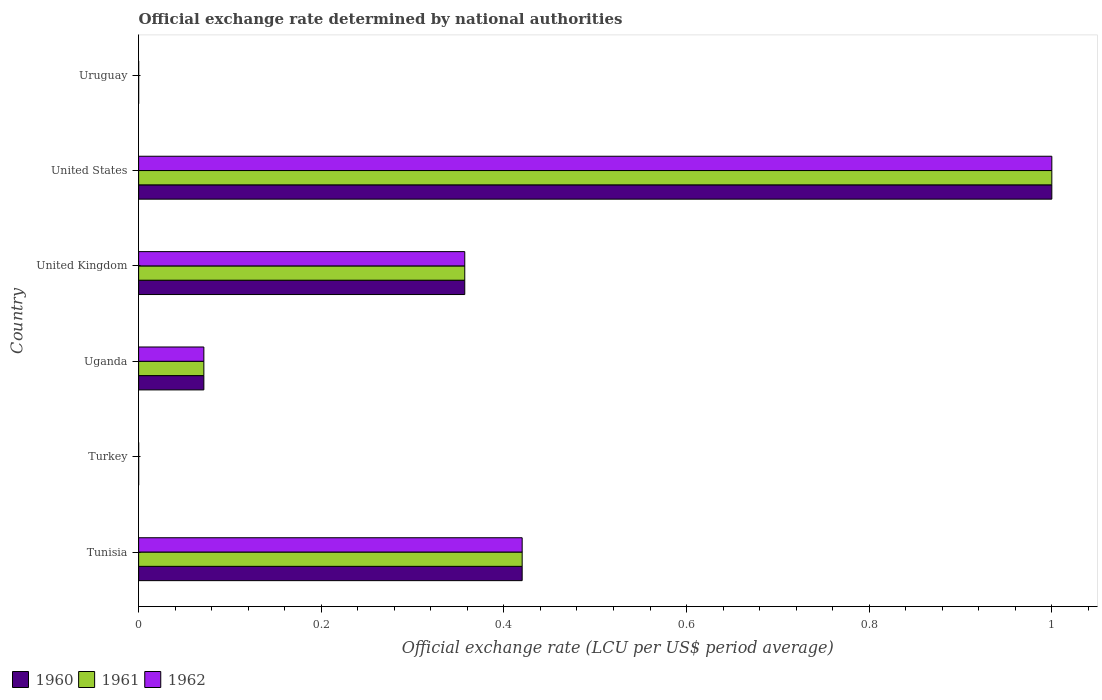How many different coloured bars are there?
Provide a succinct answer. 3. How many bars are there on the 5th tick from the top?
Offer a very short reply. 3. What is the official exchange rate in 1960 in Uruguay?
Your answer should be very brief. 1.12966666666667e-5. Across all countries, what is the minimum official exchange rate in 1961?
Your answer should be compact. 9.02e-6. What is the total official exchange rate in 1962 in the graph?
Make the answer very short. 1.85. What is the difference between the official exchange rate in 1962 in United Kingdom and that in Uruguay?
Make the answer very short. 0.36. What is the difference between the official exchange rate in 1962 in Uganda and the official exchange rate in 1960 in United States?
Provide a short and direct response. -0.93. What is the average official exchange rate in 1961 per country?
Provide a succinct answer. 0.31. What is the ratio of the official exchange rate in 1961 in Tunisia to that in Uruguay?
Your answer should be compact. 3.82e+04. What is the difference between the highest and the second highest official exchange rate in 1961?
Ensure brevity in your answer.  0.58. What is the difference between the highest and the lowest official exchange rate in 1960?
Your answer should be compact. 1. How many bars are there?
Ensure brevity in your answer.  18. Are all the bars in the graph horizontal?
Ensure brevity in your answer.  Yes. How many countries are there in the graph?
Offer a very short reply. 6. What is the difference between two consecutive major ticks on the X-axis?
Give a very brief answer. 0.2. Does the graph contain grids?
Your response must be concise. No. How many legend labels are there?
Ensure brevity in your answer.  3. What is the title of the graph?
Provide a succinct answer. Official exchange rate determined by national authorities. What is the label or title of the X-axis?
Ensure brevity in your answer.  Official exchange rate (LCU per US$ period average). What is the Official exchange rate (LCU per US$ period average) in 1960 in Tunisia?
Keep it short and to the point. 0.42. What is the Official exchange rate (LCU per US$ period average) in 1961 in Tunisia?
Ensure brevity in your answer.  0.42. What is the Official exchange rate (LCU per US$ period average) in 1962 in Tunisia?
Provide a short and direct response. 0.42. What is the Official exchange rate (LCU per US$ period average) of 1960 in Turkey?
Your response must be concise. 9.01691666658333e-6. What is the Official exchange rate (LCU per US$ period average) of 1961 in Turkey?
Keep it short and to the point. 9.02e-6. What is the Official exchange rate (LCU per US$ period average) of 1962 in Turkey?
Keep it short and to the point. 9.02e-6. What is the Official exchange rate (LCU per US$ period average) in 1960 in Uganda?
Your answer should be very brief. 0.07. What is the Official exchange rate (LCU per US$ period average) of 1961 in Uganda?
Keep it short and to the point. 0.07. What is the Official exchange rate (LCU per US$ period average) in 1962 in Uganda?
Make the answer very short. 0.07. What is the Official exchange rate (LCU per US$ period average) of 1960 in United Kingdom?
Provide a short and direct response. 0.36. What is the Official exchange rate (LCU per US$ period average) in 1961 in United Kingdom?
Your answer should be compact. 0.36. What is the Official exchange rate (LCU per US$ period average) of 1962 in United Kingdom?
Your answer should be very brief. 0.36. What is the Official exchange rate (LCU per US$ period average) of 1961 in United States?
Provide a succinct answer. 1. What is the Official exchange rate (LCU per US$ period average) of 1962 in United States?
Offer a terse response. 1. What is the Official exchange rate (LCU per US$ period average) in 1960 in Uruguay?
Make the answer very short. 1.12966666666667e-5. What is the Official exchange rate (LCU per US$ period average) of 1961 in Uruguay?
Ensure brevity in your answer.  1.10091666666667e-5. What is the Official exchange rate (LCU per US$ period average) in 1962 in Uruguay?
Provide a short and direct response. 1.098e-5. Across all countries, what is the maximum Official exchange rate (LCU per US$ period average) of 1960?
Offer a terse response. 1. Across all countries, what is the maximum Official exchange rate (LCU per US$ period average) in 1961?
Make the answer very short. 1. Across all countries, what is the minimum Official exchange rate (LCU per US$ period average) of 1960?
Give a very brief answer. 9.01691666658333e-6. Across all countries, what is the minimum Official exchange rate (LCU per US$ period average) of 1961?
Make the answer very short. 9.02e-6. Across all countries, what is the minimum Official exchange rate (LCU per US$ period average) in 1962?
Your answer should be very brief. 9.02e-6. What is the total Official exchange rate (LCU per US$ period average) of 1960 in the graph?
Ensure brevity in your answer.  1.85. What is the total Official exchange rate (LCU per US$ period average) of 1961 in the graph?
Your response must be concise. 1.85. What is the total Official exchange rate (LCU per US$ period average) in 1962 in the graph?
Provide a succinct answer. 1.85. What is the difference between the Official exchange rate (LCU per US$ period average) of 1960 in Tunisia and that in Turkey?
Make the answer very short. 0.42. What is the difference between the Official exchange rate (LCU per US$ period average) of 1961 in Tunisia and that in Turkey?
Provide a short and direct response. 0.42. What is the difference between the Official exchange rate (LCU per US$ period average) in 1962 in Tunisia and that in Turkey?
Give a very brief answer. 0.42. What is the difference between the Official exchange rate (LCU per US$ period average) of 1960 in Tunisia and that in Uganda?
Provide a succinct answer. 0.35. What is the difference between the Official exchange rate (LCU per US$ period average) of 1961 in Tunisia and that in Uganda?
Offer a very short reply. 0.35. What is the difference between the Official exchange rate (LCU per US$ period average) of 1962 in Tunisia and that in Uganda?
Your answer should be very brief. 0.35. What is the difference between the Official exchange rate (LCU per US$ period average) in 1960 in Tunisia and that in United Kingdom?
Offer a very short reply. 0.06. What is the difference between the Official exchange rate (LCU per US$ period average) in 1961 in Tunisia and that in United Kingdom?
Your answer should be compact. 0.06. What is the difference between the Official exchange rate (LCU per US$ period average) of 1962 in Tunisia and that in United Kingdom?
Your answer should be very brief. 0.06. What is the difference between the Official exchange rate (LCU per US$ period average) in 1960 in Tunisia and that in United States?
Offer a very short reply. -0.58. What is the difference between the Official exchange rate (LCU per US$ period average) of 1961 in Tunisia and that in United States?
Ensure brevity in your answer.  -0.58. What is the difference between the Official exchange rate (LCU per US$ period average) of 1962 in Tunisia and that in United States?
Your answer should be compact. -0.58. What is the difference between the Official exchange rate (LCU per US$ period average) in 1960 in Tunisia and that in Uruguay?
Provide a short and direct response. 0.42. What is the difference between the Official exchange rate (LCU per US$ period average) of 1961 in Tunisia and that in Uruguay?
Offer a terse response. 0.42. What is the difference between the Official exchange rate (LCU per US$ period average) of 1962 in Tunisia and that in Uruguay?
Ensure brevity in your answer.  0.42. What is the difference between the Official exchange rate (LCU per US$ period average) of 1960 in Turkey and that in Uganda?
Offer a terse response. -0.07. What is the difference between the Official exchange rate (LCU per US$ period average) of 1961 in Turkey and that in Uganda?
Give a very brief answer. -0.07. What is the difference between the Official exchange rate (LCU per US$ period average) in 1962 in Turkey and that in Uganda?
Make the answer very short. -0.07. What is the difference between the Official exchange rate (LCU per US$ period average) of 1960 in Turkey and that in United Kingdom?
Your answer should be compact. -0.36. What is the difference between the Official exchange rate (LCU per US$ period average) in 1961 in Turkey and that in United Kingdom?
Provide a succinct answer. -0.36. What is the difference between the Official exchange rate (LCU per US$ period average) in 1962 in Turkey and that in United Kingdom?
Your answer should be very brief. -0.36. What is the difference between the Official exchange rate (LCU per US$ period average) in 1960 in Turkey and that in Uruguay?
Offer a terse response. -0. What is the difference between the Official exchange rate (LCU per US$ period average) of 1960 in Uganda and that in United Kingdom?
Provide a short and direct response. -0.29. What is the difference between the Official exchange rate (LCU per US$ period average) in 1961 in Uganda and that in United Kingdom?
Make the answer very short. -0.29. What is the difference between the Official exchange rate (LCU per US$ period average) in 1962 in Uganda and that in United Kingdom?
Give a very brief answer. -0.29. What is the difference between the Official exchange rate (LCU per US$ period average) in 1960 in Uganda and that in United States?
Provide a short and direct response. -0.93. What is the difference between the Official exchange rate (LCU per US$ period average) of 1961 in Uganda and that in United States?
Offer a very short reply. -0.93. What is the difference between the Official exchange rate (LCU per US$ period average) in 1962 in Uganda and that in United States?
Keep it short and to the point. -0.93. What is the difference between the Official exchange rate (LCU per US$ period average) of 1960 in Uganda and that in Uruguay?
Provide a short and direct response. 0.07. What is the difference between the Official exchange rate (LCU per US$ period average) in 1961 in Uganda and that in Uruguay?
Provide a short and direct response. 0.07. What is the difference between the Official exchange rate (LCU per US$ period average) of 1962 in Uganda and that in Uruguay?
Offer a very short reply. 0.07. What is the difference between the Official exchange rate (LCU per US$ period average) of 1960 in United Kingdom and that in United States?
Your response must be concise. -0.64. What is the difference between the Official exchange rate (LCU per US$ period average) of 1961 in United Kingdom and that in United States?
Offer a terse response. -0.64. What is the difference between the Official exchange rate (LCU per US$ period average) in 1962 in United Kingdom and that in United States?
Provide a succinct answer. -0.64. What is the difference between the Official exchange rate (LCU per US$ period average) of 1960 in United Kingdom and that in Uruguay?
Keep it short and to the point. 0.36. What is the difference between the Official exchange rate (LCU per US$ period average) in 1961 in United Kingdom and that in Uruguay?
Your answer should be very brief. 0.36. What is the difference between the Official exchange rate (LCU per US$ period average) in 1962 in United Kingdom and that in Uruguay?
Provide a succinct answer. 0.36. What is the difference between the Official exchange rate (LCU per US$ period average) in 1961 in United States and that in Uruguay?
Your answer should be compact. 1. What is the difference between the Official exchange rate (LCU per US$ period average) of 1962 in United States and that in Uruguay?
Provide a succinct answer. 1. What is the difference between the Official exchange rate (LCU per US$ period average) in 1960 in Tunisia and the Official exchange rate (LCU per US$ period average) in 1961 in Turkey?
Keep it short and to the point. 0.42. What is the difference between the Official exchange rate (LCU per US$ period average) in 1960 in Tunisia and the Official exchange rate (LCU per US$ period average) in 1962 in Turkey?
Make the answer very short. 0.42. What is the difference between the Official exchange rate (LCU per US$ period average) in 1961 in Tunisia and the Official exchange rate (LCU per US$ period average) in 1962 in Turkey?
Offer a terse response. 0.42. What is the difference between the Official exchange rate (LCU per US$ period average) in 1960 in Tunisia and the Official exchange rate (LCU per US$ period average) in 1961 in Uganda?
Ensure brevity in your answer.  0.35. What is the difference between the Official exchange rate (LCU per US$ period average) of 1960 in Tunisia and the Official exchange rate (LCU per US$ period average) of 1962 in Uganda?
Give a very brief answer. 0.35. What is the difference between the Official exchange rate (LCU per US$ period average) of 1961 in Tunisia and the Official exchange rate (LCU per US$ period average) of 1962 in Uganda?
Keep it short and to the point. 0.35. What is the difference between the Official exchange rate (LCU per US$ period average) in 1960 in Tunisia and the Official exchange rate (LCU per US$ period average) in 1961 in United Kingdom?
Keep it short and to the point. 0.06. What is the difference between the Official exchange rate (LCU per US$ period average) in 1960 in Tunisia and the Official exchange rate (LCU per US$ period average) in 1962 in United Kingdom?
Provide a succinct answer. 0.06. What is the difference between the Official exchange rate (LCU per US$ period average) in 1961 in Tunisia and the Official exchange rate (LCU per US$ period average) in 1962 in United Kingdom?
Your answer should be very brief. 0.06. What is the difference between the Official exchange rate (LCU per US$ period average) of 1960 in Tunisia and the Official exchange rate (LCU per US$ period average) of 1961 in United States?
Offer a very short reply. -0.58. What is the difference between the Official exchange rate (LCU per US$ period average) of 1960 in Tunisia and the Official exchange rate (LCU per US$ period average) of 1962 in United States?
Offer a very short reply. -0.58. What is the difference between the Official exchange rate (LCU per US$ period average) in 1961 in Tunisia and the Official exchange rate (LCU per US$ period average) in 1962 in United States?
Keep it short and to the point. -0.58. What is the difference between the Official exchange rate (LCU per US$ period average) of 1960 in Tunisia and the Official exchange rate (LCU per US$ period average) of 1961 in Uruguay?
Offer a terse response. 0.42. What is the difference between the Official exchange rate (LCU per US$ period average) of 1960 in Tunisia and the Official exchange rate (LCU per US$ period average) of 1962 in Uruguay?
Your answer should be very brief. 0.42. What is the difference between the Official exchange rate (LCU per US$ period average) in 1961 in Tunisia and the Official exchange rate (LCU per US$ period average) in 1962 in Uruguay?
Provide a succinct answer. 0.42. What is the difference between the Official exchange rate (LCU per US$ period average) in 1960 in Turkey and the Official exchange rate (LCU per US$ period average) in 1961 in Uganda?
Your response must be concise. -0.07. What is the difference between the Official exchange rate (LCU per US$ period average) in 1960 in Turkey and the Official exchange rate (LCU per US$ period average) in 1962 in Uganda?
Offer a very short reply. -0.07. What is the difference between the Official exchange rate (LCU per US$ period average) in 1961 in Turkey and the Official exchange rate (LCU per US$ period average) in 1962 in Uganda?
Offer a very short reply. -0.07. What is the difference between the Official exchange rate (LCU per US$ period average) in 1960 in Turkey and the Official exchange rate (LCU per US$ period average) in 1961 in United Kingdom?
Give a very brief answer. -0.36. What is the difference between the Official exchange rate (LCU per US$ period average) of 1960 in Turkey and the Official exchange rate (LCU per US$ period average) of 1962 in United Kingdom?
Your answer should be compact. -0.36. What is the difference between the Official exchange rate (LCU per US$ period average) of 1961 in Turkey and the Official exchange rate (LCU per US$ period average) of 1962 in United Kingdom?
Offer a very short reply. -0.36. What is the difference between the Official exchange rate (LCU per US$ period average) of 1961 in Turkey and the Official exchange rate (LCU per US$ period average) of 1962 in Uruguay?
Your response must be concise. -0. What is the difference between the Official exchange rate (LCU per US$ period average) of 1960 in Uganda and the Official exchange rate (LCU per US$ period average) of 1961 in United Kingdom?
Give a very brief answer. -0.29. What is the difference between the Official exchange rate (LCU per US$ period average) of 1960 in Uganda and the Official exchange rate (LCU per US$ period average) of 1962 in United Kingdom?
Give a very brief answer. -0.29. What is the difference between the Official exchange rate (LCU per US$ period average) of 1961 in Uganda and the Official exchange rate (LCU per US$ period average) of 1962 in United Kingdom?
Provide a succinct answer. -0.29. What is the difference between the Official exchange rate (LCU per US$ period average) of 1960 in Uganda and the Official exchange rate (LCU per US$ period average) of 1961 in United States?
Offer a very short reply. -0.93. What is the difference between the Official exchange rate (LCU per US$ period average) in 1960 in Uganda and the Official exchange rate (LCU per US$ period average) in 1962 in United States?
Provide a short and direct response. -0.93. What is the difference between the Official exchange rate (LCU per US$ period average) of 1961 in Uganda and the Official exchange rate (LCU per US$ period average) of 1962 in United States?
Give a very brief answer. -0.93. What is the difference between the Official exchange rate (LCU per US$ period average) of 1960 in Uganda and the Official exchange rate (LCU per US$ period average) of 1961 in Uruguay?
Provide a short and direct response. 0.07. What is the difference between the Official exchange rate (LCU per US$ period average) in 1960 in Uganda and the Official exchange rate (LCU per US$ period average) in 1962 in Uruguay?
Offer a very short reply. 0.07. What is the difference between the Official exchange rate (LCU per US$ period average) in 1961 in Uganda and the Official exchange rate (LCU per US$ period average) in 1962 in Uruguay?
Your response must be concise. 0.07. What is the difference between the Official exchange rate (LCU per US$ period average) in 1960 in United Kingdom and the Official exchange rate (LCU per US$ period average) in 1961 in United States?
Your answer should be very brief. -0.64. What is the difference between the Official exchange rate (LCU per US$ period average) in 1960 in United Kingdom and the Official exchange rate (LCU per US$ period average) in 1962 in United States?
Provide a succinct answer. -0.64. What is the difference between the Official exchange rate (LCU per US$ period average) in 1961 in United Kingdom and the Official exchange rate (LCU per US$ period average) in 1962 in United States?
Keep it short and to the point. -0.64. What is the difference between the Official exchange rate (LCU per US$ period average) in 1960 in United Kingdom and the Official exchange rate (LCU per US$ period average) in 1961 in Uruguay?
Ensure brevity in your answer.  0.36. What is the difference between the Official exchange rate (LCU per US$ period average) in 1960 in United Kingdom and the Official exchange rate (LCU per US$ period average) in 1962 in Uruguay?
Make the answer very short. 0.36. What is the difference between the Official exchange rate (LCU per US$ period average) of 1961 in United Kingdom and the Official exchange rate (LCU per US$ period average) of 1962 in Uruguay?
Provide a succinct answer. 0.36. What is the difference between the Official exchange rate (LCU per US$ period average) in 1961 in United States and the Official exchange rate (LCU per US$ period average) in 1962 in Uruguay?
Your response must be concise. 1. What is the average Official exchange rate (LCU per US$ period average) of 1960 per country?
Make the answer very short. 0.31. What is the average Official exchange rate (LCU per US$ period average) of 1961 per country?
Offer a very short reply. 0.31. What is the average Official exchange rate (LCU per US$ period average) in 1962 per country?
Give a very brief answer. 0.31. What is the difference between the Official exchange rate (LCU per US$ period average) in 1960 and Official exchange rate (LCU per US$ period average) in 1961 in Tunisia?
Provide a short and direct response. 0. What is the difference between the Official exchange rate (LCU per US$ period average) in 1960 and Official exchange rate (LCU per US$ period average) in 1962 in Tunisia?
Provide a short and direct response. 0. What is the difference between the Official exchange rate (LCU per US$ period average) of 1960 and Official exchange rate (LCU per US$ period average) of 1961 in Uganda?
Provide a short and direct response. 0. What is the difference between the Official exchange rate (LCU per US$ period average) of 1960 and Official exchange rate (LCU per US$ period average) of 1962 in Uganda?
Offer a very short reply. 0. What is the difference between the Official exchange rate (LCU per US$ period average) of 1960 and Official exchange rate (LCU per US$ period average) of 1961 in United Kingdom?
Give a very brief answer. 0. What is the difference between the Official exchange rate (LCU per US$ period average) of 1960 and Official exchange rate (LCU per US$ period average) of 1961 in Uruguay?
Your response must be concise. 0. What is the ratio of the Official exchange rate (LCU per US$ period average) in 1960 in Tunisia to that in Turkey?
Provide a short and direct response. 4.66e+04. What is the ratio of the Official exchange rate (LCU per US$ period average) in 1961 in Tunisia to that in Turkey?
Your response must be concise. 4.66e+04. What is the ratio of the Official exchange rate (LCU per US$ period average) of 1962 in Tunisia to that in Turkey?
Your response must be concise. 4.66e+04. What is the ratio of the Official exchange rate (LCU per US$ period average) of 1960 in Tunisia to that in Uganda?
Your response must be concise. 5.88. What is the ratio of the Official exchange rate (LCU per US$ period average) in 1961 in Tunisia to that in Uganda?
Offer a very short reply. 5.88. What is the ratio of the Official exchange rate (LCU per US$ period average) in 1962 in Tunisia to that in Uganda?
Your answer should be very brief. 5.88. What is the ratio of the Official exchange rate (LCU per US$ period average) in 1960 in Tunisia to that in United Kingdom?
Your answer should be compact. 1.18. What is the ratio of the Official exchange rate (LCU per US$ period average) of 1961 in Tunisia to that in United Kingdom?
Provide a succinct answer. 1.18. What is the ratio of the Official exchange rate (LCU per US$ period average) in 1962 in Tunisia to that in United Kingdom?
Make the answer very short. 1.18. What is the ratio of the Official exchange rate (LCU per US$ period average) in 1960 in Tunisia to that in United States?
Your response must be concise. 0.42. What is the ratio of the Official exchange rate (LCU per US$ period average) of 1961 in Tunisia to that in United States?
Make the answer very short. 0.42. What is the ratio of the Official exchange rate (LCU per US$ period average) of 1962 in Tunisia to that in United States?
Your response must be concise. 0.42. What is the ratio of the Official exchange rate (LCU per US$ period average) in 1960 in Tunisia to that in Uruguay?
Offer a terse response. 3.72e+04. What is the ratio of the Official exchange rate (LCU per US$ period average) in 1961 in Tunisia to that in Uruguay?
Offer a terse response. 3.82e+04. What is the ratio of the Official exchange rate (LCU per US$ period average) in 1962 in Tunisia to that in Uruguay?
Provide a short and direct response. 3.83e+04. What is the ratio of the Official exchange rate (LCU per US$ period average) of 1961 in Turkey to that in United Kingdom?
Offer a very short reply. 0. What is the ratio of the Official exchange rate (LCU per US$ period average) in 1962 in Turkey to that in United Kingdom?
Offer a terse response. 0. What is the ratio of the Official exchange rate (LCU per US$ period average) of 1962 in Turkey to that in United States?
Offer a very short reply. 0. What is the ratio of the Official exchange rate (LCU per US$ period average) in 1960 in Turkey to that in Uruguay?
Make the answer very short. 0.8. What is the ratio of the Official exchange rate (LCU per US$ period average) in 1961 in Turkey to that in Uruguay?
Provide a succinct answer. 0.82. What is the ratio of the Official exchange rate (LCU per US$ period average) in 1962 in Turkey to that in Uruguay?
Your answer should be compact. 0.82. What is the ratio of the Official exchange rate (LCU per US$ period average) of 1960 in Uganda to that in United Kingdom?
Your answer should be very brief. 0.2. What is the ratio of the Official exchange rate (LCU per US$ period average) in 1962 in Uganda to that in United Kingdom?
Provide a short and direct response. 0.2. What is the ratio of the Official exchange rate (LCU per US$ period average) of 1960 in Uganda to that in United States?
Make the answer very short. 0.07. What is the ratio of the Official exchange rate (LCU per US$ period average) of 1961 in Uganda to that in United States?
Your response must be concise. 0.07. What is the ratio of the Official exchange rate (LCU per US$ period average) of 1962 in Uganda to that in United States?
Make the answer very short. 0.07. What is the ratio of the Official exchange rate (LCU per US$ period average) of 1960 in Uganda to that in Uruguay?
Keep it short and to the point. 6323.1. What is the ratio of the Official exchange rate (LCU per US$ period average) of 1961 in Uganda to that in Uruguay?
Provide a succinct answer. 6488.23. What is the ratio of the Official exchange rate (LCU per US$ period average) in 1962 in Uganda to that in Uruguay?
Offer a very short reply. 6505.46. What is the ratio of the Official exchange rate (LCU per US$ period average) in 1960 in United Kingdom to that in United States?
Provide a short and direct response. 0.36. What is the ratio of the Official exchange rate (LCU per US$ period average) in 1961 in United Kingdom to that in United States?
Ensure brevity in your answer.  0.36. What is the ratio of the Official exchange rate (LCU per US$ period average) in 1962 in United Kingdom to that in United States?
Your answer should be very brief. 0.36. What is the ratio of the Official exchange rate (LCU per US$ period average) in 1960 in United Kingdom to that in Uruguay?
Provide a short and direct response. 3.16e+04. What is the ratio of the Official exchange rate (LCU per US$ period average) in 1961 in United Kingdom to that in Uruguay?
Your answer should be compact. 3.24e+04. What is the ratio of the Official exchange rate (LCU per US$ period average) in 1962 in United Kingdom to that in Uruguay?
Ensure brevity in your answer.  3.25e+04. What is the ratio of the Official exchange rate (LCU per US$ period average) of 1960 in United States to that in Uruguay?
Offer a very short reply. 8.85e+04. What is the ratio of the Official exchange rate (LCU per US$ period average) of 1961 in United States to that in Uruguay?
Your answer should be compact. 9.08e+04. What is the ratio of the Official exchange rate (LCU per US$ period average) in 1962 in United States to that in Uruguay?
Give a very brief answer. 9.11e+04. What is the difference between the highest and the second highest Official exchange rate (LCU per US$ period average) in 1960?
Your answer should be compact. 0.58. What is the difference between the highest and the second highest Official exchange rate (LCU per US$ period average) in 1961?
Provide a succinct answer. 0.58. What is the difference between the highest and the second highest Official exchange rate (LCU per US$ period average) of 1962?
Keep it short and to the point. 0.58. What is the difference between the highest and the lowest Official exchange rate (LCU per US$ period average) in 1961?
Offer a very short reply. 1. What is the difference between the highest and the lowest Official exchange rate (LCU per US$ period average) of 1962?
Give a very brief answer. 1. 